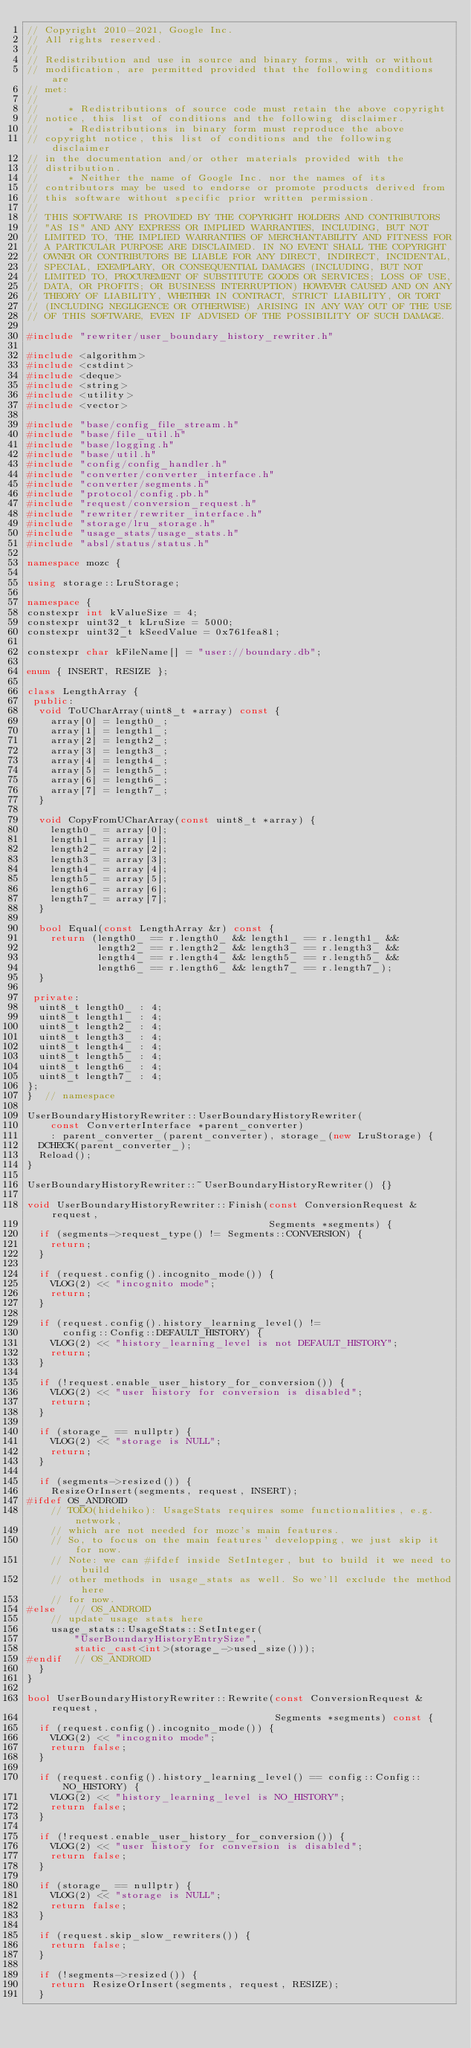<code> <loc_0><loc_0><loc_500><loc_500><_C++_>// Copyright 2010-2021, Google Inc.
// All rights reserved.
//
// Redistribution and use in source and binary forms, with or without
// modification, are permitted provided that the following conditions are
// met:
//
//     * Redistributions of source code must retain the above copyright
// notice, this list of conditions and the following disclaimer.
//     * Redistributions in binary form must reproduce the above
// copyright notice, this list of conditions and the following disclaimer
// in the documentation and/or other materials provided with the
// distribution.
//     * Neither the name of Google Inc. nor the names of its
// contributors may be used to endorse or promote products derived from
// this software without specific prior written permission.
//
// THIS SOFTWARE IS PROVIDED BY THE COPYRIGHT HOLDERS AND CONTRIBUTORS
// "AS IS" AND ANY EXPRESS OR IMPLIED WARRANTIES, INCLUDING, BUT NOT
// LIMITED TO, THE IMPLIED WARRANTIES OF MERCHANTABILITY AND FITNESS FOR
// A PARTICULAR PURPOSE ARE DISCLAIMED. IN NO EVENT SHALL THE COPYRIGHT
// OWNER OR CONTRIBUTORS BE LIABLE FOR ANY DIRECT, INDIRECT, INCIDENTAL,
// SPECIAL, EXEMPLARY, OR CONSEQUENTIAL DAMAGES (INCLUDING, BUT NOT
// LIMITED TO, PROCUREMENT OF SUBSTITUTE GOODS OR SERVICES; LOSS OF USE,
// DATA, OR PROFITS; OR BUSINESS INTERRUPTION) HOWEVER CAUSED AND ON ANY
// THEORY OF LIABILITY, WHETHER IN CONTRACT, STRICT LIABILITY, OR TORT
// (INCLUDING NEGLIGENCE OR OTHERWISE) ARISING IN ANY WAY OUT OF THE USE
// OF THIS SOFTWARE, EVEN IF ADVISED OF THE POSSIBILITY OF SUCH DAMAGE.

#include "rewriter/user_boundary_history_rewriter.h"

#include <algorithm>
#include <cstdint>
#include <deque>
#include <string>
#include <utility>
#include <vector>

#include "base/config_file_stream.h"
#include "base/file_util.h"
#include "base/logging.h"
#include "base/util.h"
#include "config/config_handler.h"
#include "converter/converter_interface.h"
#include "converter/segments.h"
#include "protocol/config.pb.h"
#include "request/conversion_request.h"
#include "rewriter/rewriter_interface.h"
#include "storage/lru_storage.h"
#include "usage_stats/usage_stats.h"
#include "absl/status/status.h"

namespace mozc {

using storage::LruStorage;

namespace {
constexpr int kValueSize = 4;
constexpr uint32_t kLruSize = 5000;
constexpr uint32_t kSeedValue = 0x761fea81;

constexpr char kFileName[] = "user://boundary.db";

enum { INSERT, RESIZE };

class LengthArray {
 public:
  void ToUCharArray(uint8_t *array) const {
    array[0] = length0_;
    array[1] = length1_;
    array[2] = length2_;
    array[3] = length3_;
    array[4] = length4_;
    array[5] = length5_;
    array[6] = length6_;
    array[7] = length7_;
  }

  void CopyFromUCharArray(const uint8_t *array) {
    length0_ = array[0];
    length1_ = array[1];
    length2_ = array[2];
    length3_ = array[3];
    length4_ = array[4];
    length5_ = array[5];
    length6_ = array[6];
    length7_ = array[7];
  }

  bool Equal(const LengthArray &r) const {
    return (length0_ == r.length0_ && length1_ == r.length1_ &&
            length2_ == r.length2_ && length3_ == r.length3_ &&
            length4_ == r.length4_ && length5_ == r.length5_ &&
            length6_ == r.length6_ && length7_ == r.length7_);
  }

 private:
  uint8_t length0_ : 4;
  uint8_t length1_ : 4;
  uint8_t length2_ : 4;
  uint8_t length3_ : 4;
  uint8_t length4_ : 4;
  uint8_t length5_ : 4;
  uint8_t length6_ : 4;
  uint8_t length7_ : 4;
};
}  // namespace

UserBoundaryHistoryRewriter::UserBoundaryHistoryRewriter(
    const ConverterInterface *parent_converter)
    : parent_converter_(parent_converter), storage_(new LruStorage) {
  DCHECK(parent_converter_);
  Reload();
}

UserBoundaryHistoryRewriter::~UserBoundaryHistoryRewriter() {}

void UserBoundaryHistoryRewriter::Finish(const ConversionRequest &request,
                                         Segments *segments) {
  if (segments->request_type() != Segments::CONVERSION) {
    return;
  }

  if (request.config().incognito_mode()) {
    VLOG(2) << "incognito mode";
    return;
  }

  if (request.config().history_learning_level() !=
      config::Config::DEFAULT_HISTORY) {
    VLOG(2) << "history_learning_level is not DEFAULT_HISTORY";
    return;
  }

  if (!request.enable_user_history_for_conversion()) {
    VLOG(2) << "user history for conversion is disabled";
    return;
  }

  if (storage_ == nullptr) {
    VLOG(2) << "storage is NULL";
    return;
  }

  if (segments->resized()) {
    ResizeOrInsert(segments, request, INSERT);
#ifdef OS_ANDROID
    // TODO(hidehiko): UsageStats requires some functionalities, e.g. network,
    // which are not needed for mozc's main features.
    // So, to focus on the main features' developping, we just skip it for now.
    // Note: we can #ifdef inside SetInteger, but to build it we need to build
    // other methods in usage_stats as well. So we'll exclude the method here
    // for now.
#else   // OS_ANDROID
    // update usage stats here
    usage_stats::UsageStats::SetInteger(
        "UserBoundaryHistoryEntrySize",
        static_cast<int>(storage_->used_size()));
#endif  // OS_ANDROID
  }
}

bool UserBoundaryHistoryRewriter::Rewrite(const ConversionRequest &request,
                                          Segments *segments) const {
  if (request.config().incognito_mode()) {
    VLOG(2) << "incognito mode";
    return false;
  }

  if (request.config().history_learning_level() == config::Config::NO_HISTORY) {
    VLOG(2) << "history_learning_level is NO_HISTORY";
    return false;
  }

  if (!request.enable_user_history_for_conversion()) {
    VLOG(2) << "user history for conversion is disabled";
    return false;
  }

  if (storage_ == nullptr) {
    VLOG(2) << "storage is NULL";
    return false;
  }

  if (request.skip_slow_rewriters()) {
    return false;
  }

  if (!segments->resized()) {
    return ResizeOrInsert(segments, request, RESIZE);
  }
</code> 